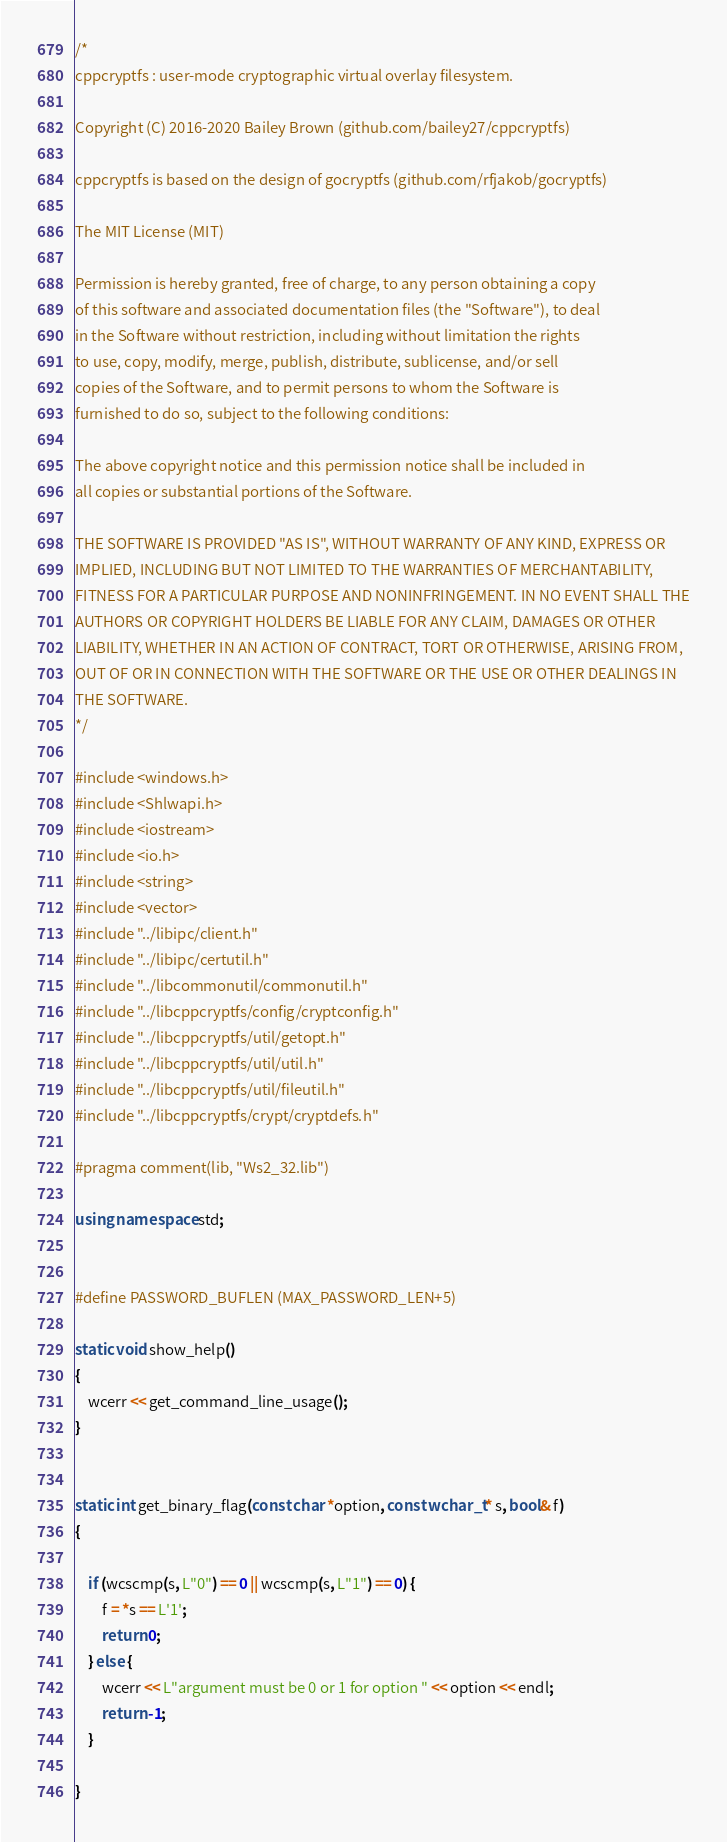<code> <loc_0><loc_0><loc_500><loc_500><_C++_>/*
cppcryptfs : user-mode cryptographic virtual overlay filesystem.

Copyright (C) 2016-2020 Bailey Brown (github.com/bailey27/cppcryptfs)

cppcryptfs is based on the design of gocryptfs (github.com/rfjakob/gocryptfs)

The MIT License (MIT)

Permission is hereby granted, free of charge, to any person obtaining a copy
of this software and associated documentation files (the "Software"), to deal
in the Software without restriction, including without limitation the rights
to use, copy, modify, merge, publish, distribute, sublicense, and/or sell
copies of the Software, and to permit persons to whom the Software is
furnished to do so, subject to the following conditions:

The above copyright notice and this permission notice shall be included in
all copies or substantial portions of the Software.

THE SOFTWARE IS PROVIDED "AS IS", WITHOUT WARRANTY OF ANY KIND, EXPRESS OR
IMPLIED, INCLUDING BUT NOT LIMITED TO THE WARRANTIES OF MERCHANTABILITY,
FITNESS FOR A PARTICULAR PURPOSE AND NONINFRINGEMENT. IN NO EVENT SHALL THE
AUTHORS OR COPYRIGHT HOLDERS BE LIABLE FOR ANY CLAIM, DAMAGES OR OTHER
LIABILITY, WHETHER IN AN ACTION OF CONTRACT, TORT OR OTHERWISE, ARISING FROM,
OUT OF OR IN CONNECTION WITH THE SOFTWARE OR THE USE OR OTHER DEALINGS IN
THE SOFTWARE.
*/

#include <windows.h>
#include <Shlwapi.h>
#include <iostream>
#include <io.h>
#include <string>
#include <vector>
#include "../libipc/client.h"
#include "../libipc/certutil.h"
#include "../libcommonutil/commonutil.h"
#include "../libcppcryptfs/config/cryptconfig.h"
#include "../libcppcryptfs/util/getopt.h"
#include "../libcppcryptfs/util/util.h"
#include "../libcppcryptfs/util/fileutil.h"
#include "../libcppcryptfs/crypt/cryptdefs.h"

#pragma comment(lib, "Ws2_32.lib")

using namespace std;


#define PASSWORD_BUFLEN (MAX_PASSWORD_LEN+5)

static void show_help()
{
    wcerr << get_command_line_usage();
}


static int get_binary_flag(const char *option, const wchar_t* s, bool& f)
{

    if (wcscmp(s, L"0") == 0 || wcscmp(s, L"1") == 0) {
        f = *s == L'1';
        return 0;
    } else {
        wcerr << L"argument must be 0 or 1 for option " << option << endl;
        return -1;
    }
        
}
</code> 